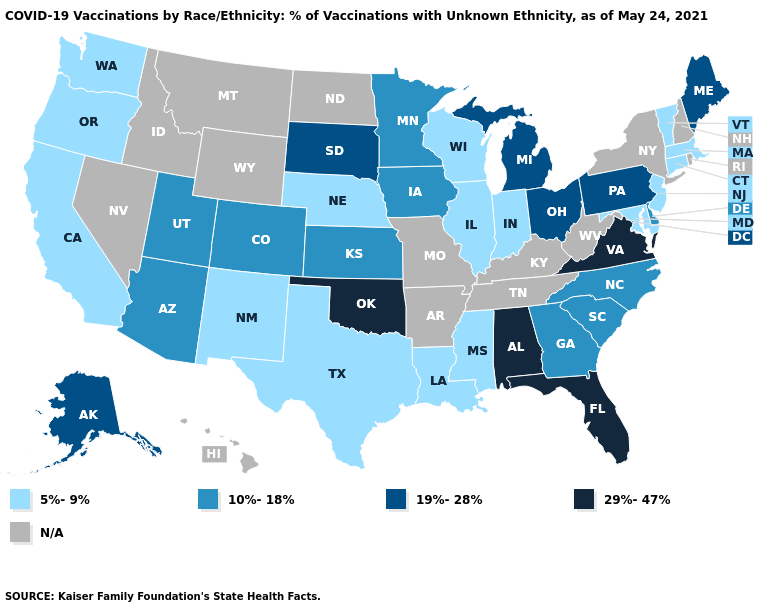What is the lowest value in states that border Alabama?
Quick response, please. 5%-9%. Does Oregon have the lowest value in the USA?
Concise answer only. Yes. What is the highest value in states that border California?
Short answer required. 10%-18%. Name the states that have a value in the range 5%-9%?
Keep it brief. California, Connecticut, Illinois, Indiana, Louisiana, Maryland, Massachusetts, Mississippi, Nebraska, New Jersey, New Mexico, Oregon, Texas, Vermont, Washington, Wisconsin. What is the lowest value in the USA?
Quick response, please. 5%-9%. What is the lowest value in states that border North Carolina?
Answer briefly. 10%-18%. What is the value of Michigan?
Concise answer only. 19%-28%. Does the map have missing data?
Quick response, please. Yes. Among the states that border Michigan , which have the highest value?
Quick response, please. Ohio. What is the value of New York?
Quick response, please. N/A. Does New Jersey have the lowest value in the USA?
Write a very short answer. Yes. Does the map have missing data?
Give a very brief answer. Yes. Name the states that have a value in the range 19%-28%?
Give a very brief answer. Alaska, Maine, Michigan, Ohio, Pennsylvania, South Dakota. 